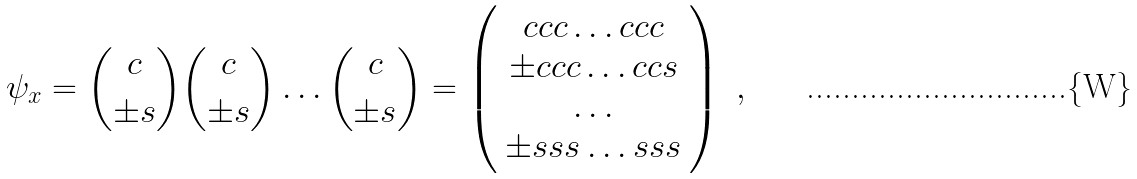Convert formula to latex. <formula><loc_0><loc_0><loc_500><loc_500>\psi _ { x } = { c \choose \pm s } { c \choose \pm s } \dots { c \choose \pm s } = \left ( \begin{array} { c } c c c \dots c c c \\ \pm c c c \dots c c s \\ \dots \\ \pm s s s \dots s s s \end{array} \right ) \ ,</formula> 